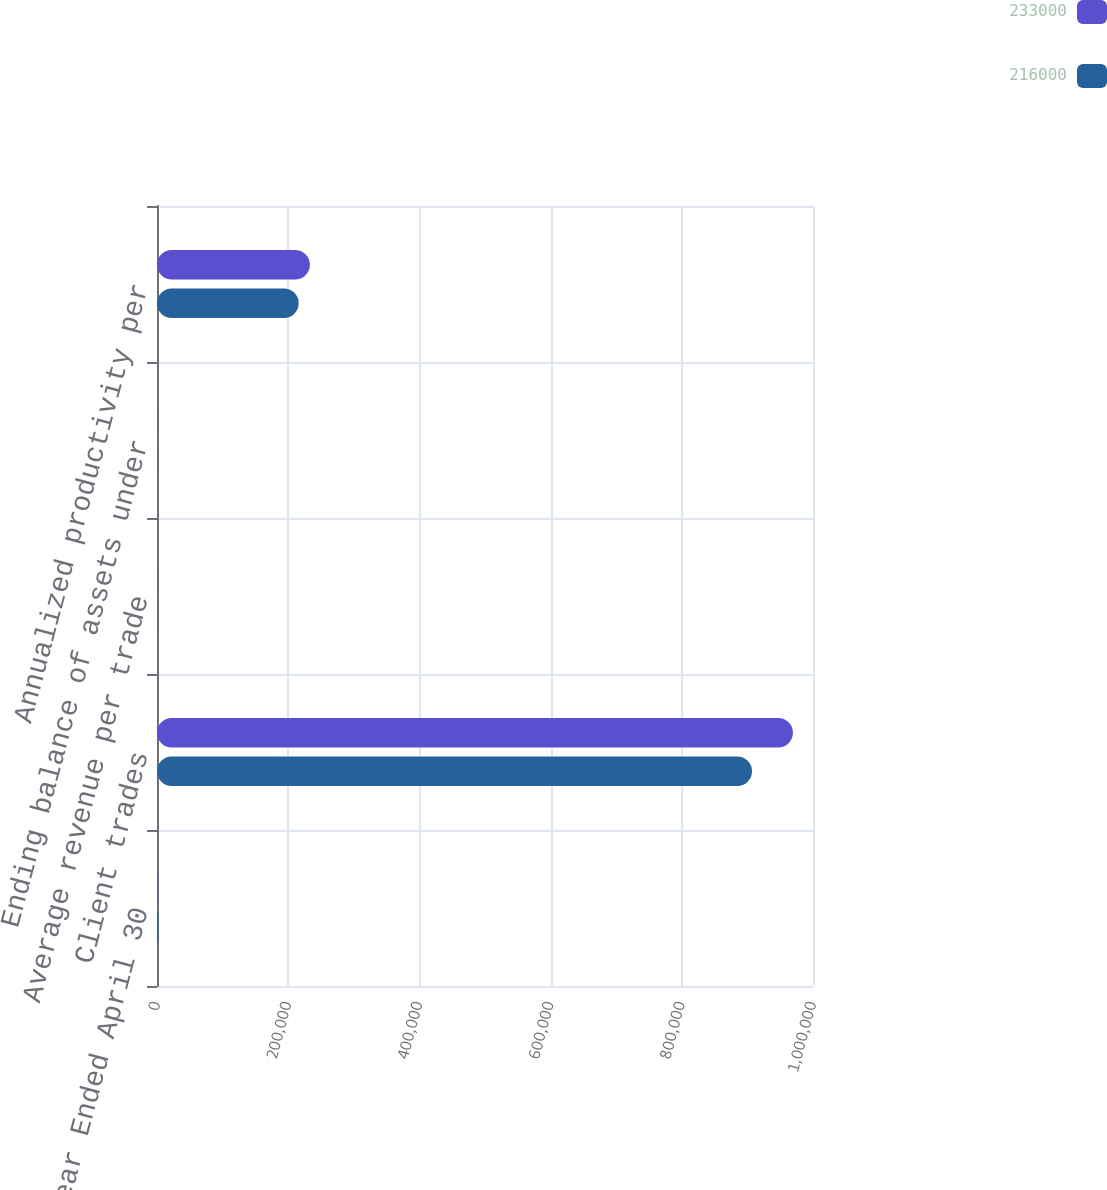Convert chart to OTSL. <chart><loc_0><loc_0><loc_500><loc_500><stacked_bar_chart><ecel><fcel>Year Ended April 30<fcel>Client trades<fcel>Average revenue per trade<fcel>Ending balance of assets under<fcel>Annualized productivity per<nl><fcel>233000<fcel>2008<fcel>969364<fcel>120.22<fcel>32.1<fcel>233000<nl><fcel>216000<fcel>2007<fcel>907075<fcel>126.54<fcel>33.1<fcel>216000<nl></chart> 